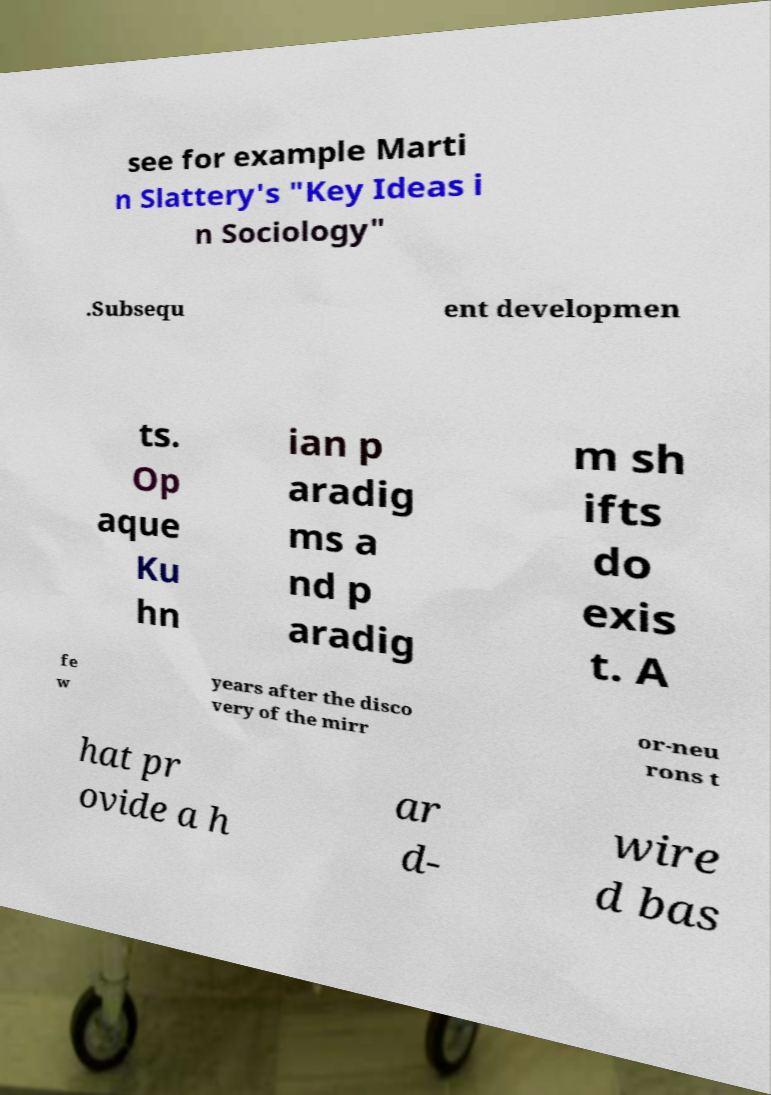There's text embedded in this image that I need extracted. Can you transcribe it verbatim? see for example Marti n Slattery's "Key Ideas i n Sociology" .Subsequ ent developmen ts. Op aque Ku hn ian p aradig ms a nd p aradig m sh ifts do exis t. A fe w years after the disco very of the mirr or-neu rons t hat pr ovide a h ar d- wire d bas 